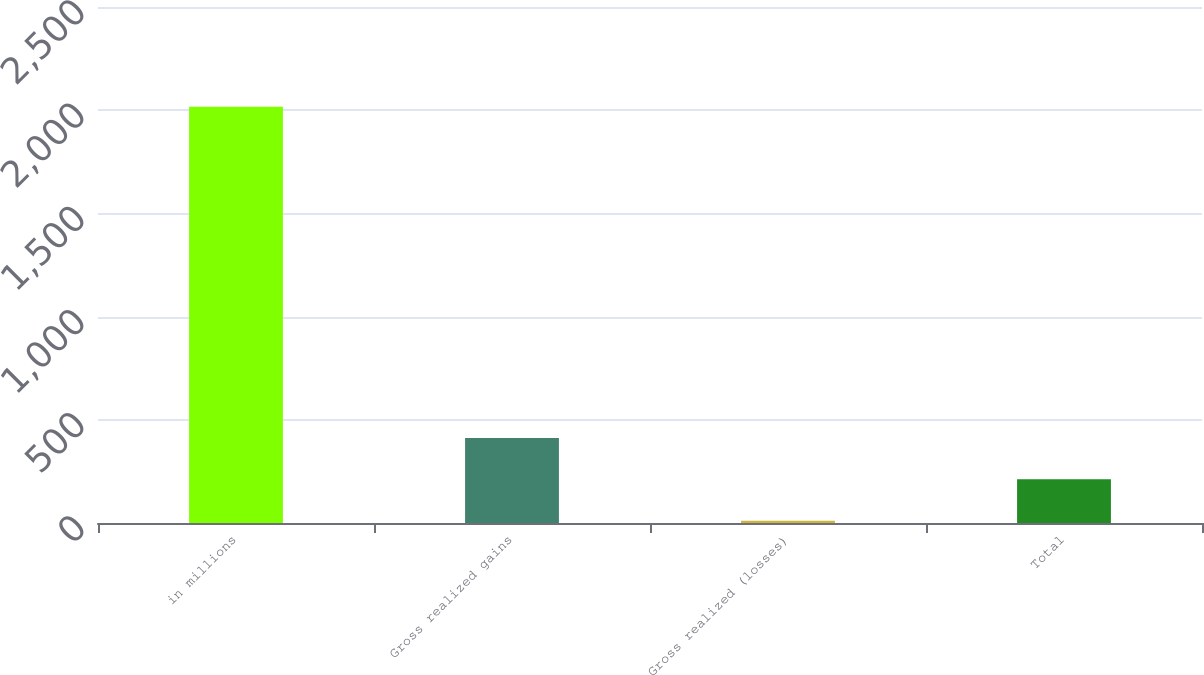Convert chart. <chart><loc_0><loc_0><loc_500><loc_500><bar_chart><fcel>in millions<fcel>Gross realized gains<fcel>Gross realized (losses)<fcel>Total<nl><fcel>2017<fcel>412.2<fcel>11<fcel>211.6<nl></chart> 